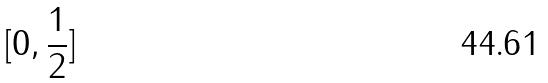Convert formula to latex. <formula><loc_0><loc_0><loc_500><loc_500>[ 0 , \frac { 1 } { 2 } ]</formula> 